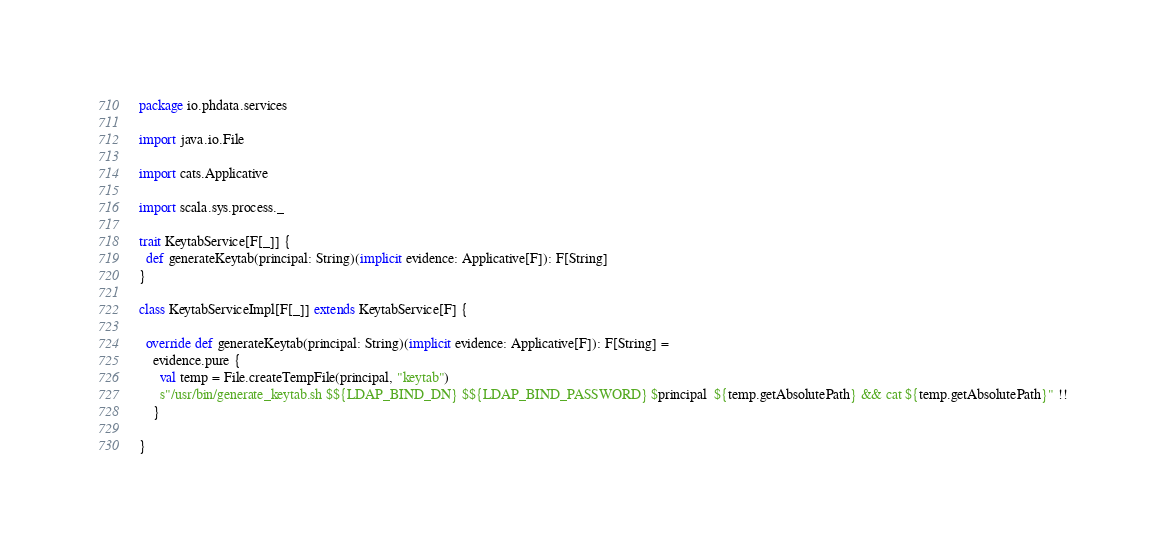<code> <loc_0><loc_0><loc_500><loc_500><_Scala_>package io.phdata.services

import java.io.File

import cats.Applicative

import scala.sys.process._

trait KeytabService[F[_]] {
  def generateKeytab(principal: String)(implicit evidence: Applicative[F]): F[String]
}

class KeytabServiceImpl[F[_]] extends KeytabService[F] {

  override def generateKeytab(principal: String)(implicit evidence: Applicative[F]): F[String] =
    evidence.pure {
      val temp = File.createTempFile(principal, "keytab")
      s"/usr/bin/generate_keytab.sh $${LDAP_BIND_DN} $${LDAP_BIND_PASSWORD} $principal  ${temp.getAbsolutePath} && cat ${temp.getAbsolutePath}" !!
    }

}
</code> 